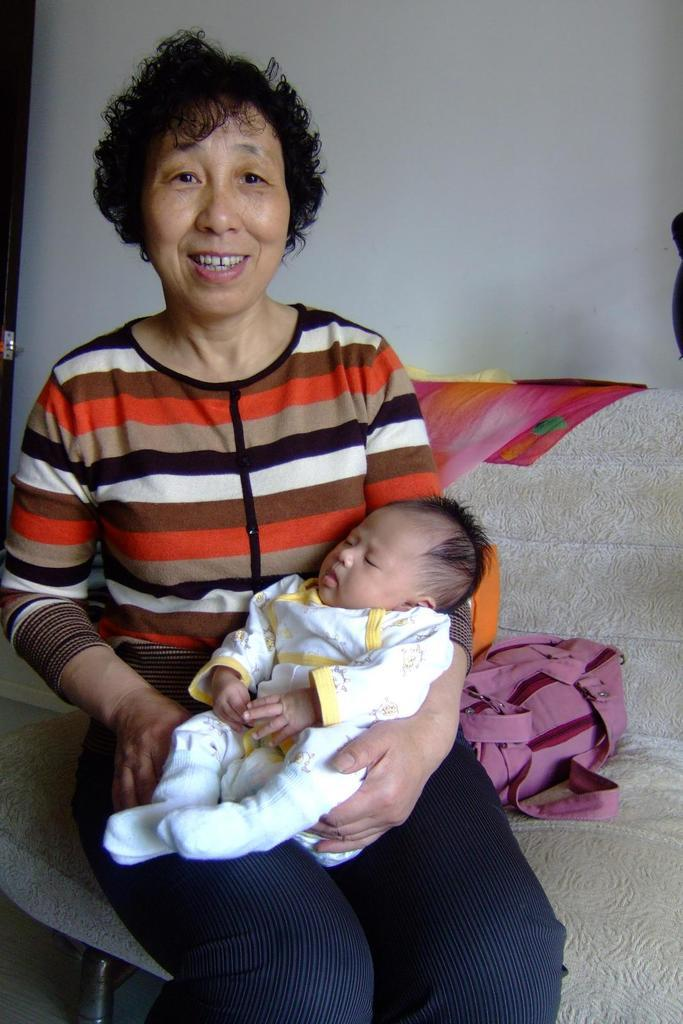Who is the main subject in the image? There is a woman in the image. What is the woman doing in the image? The woman is seated on a sofa and smiling. Is there anyone else in the image besides the woman? Yes, the woman is holding a baby. What else can be seen in the image? There is a bag visible in the image. What type of branch can be seen growing from the baby's head in the image? There is no branch growing from the baby's head in the image; the baby is simply being held by the woman. 